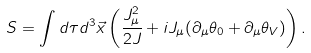<formula> <loc_0><loc_0><loc_500><loc_500>S = \int d \tau d ^ { 3 } \vec { x } \left ( \frac { J _ { \mu } ^ { 2 } } { 2 J } + i J _ { \mu } ( \partial _ { \mu } \theta _ { 0 } + \partial _ { \mu } \theta _ { V } ) \right ) .</formula> 